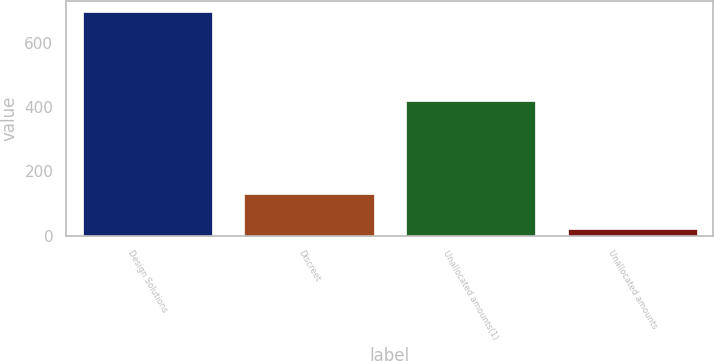Convert chart to OTSL. <chart><loc_0><loc_0><loc_500><loc_500><bar_chart><fcel>Design Solutions<fcel>Discreet<fcel>Unallocated amounts(1)<fcel>Unallocated amounts<nl><fcel>696.4<fcel>128.5<fcel>419<fcel>19.5<nl></chart> 